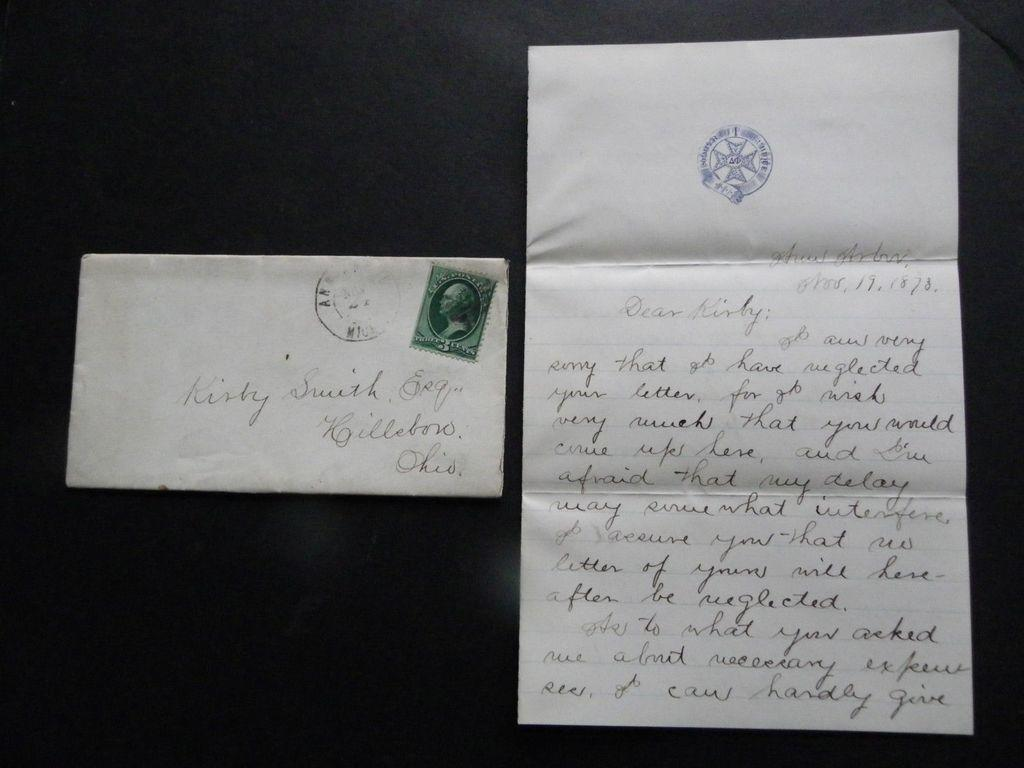Provide a one-sentence caption for the provided image. Fancy script graces the envelope and a letter written to Kirby Smith. 